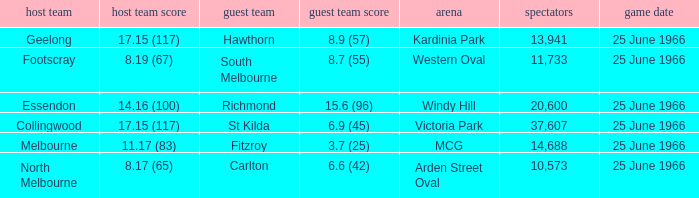15 (117) and the away team registered St Kilda. 